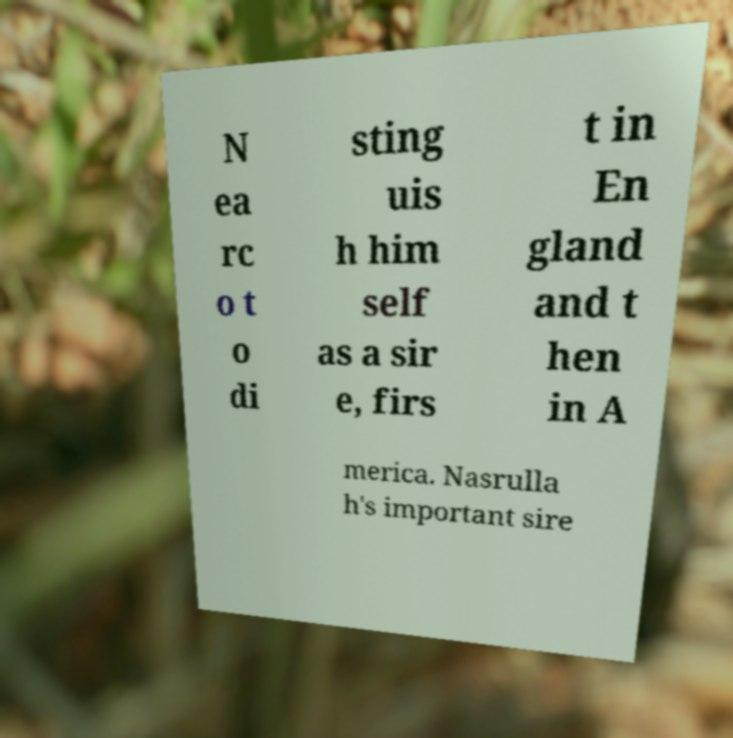There's text embedded in this image that I need extracted. Can you transcribe it verbatim? N ea rc o t o di sting uis h him self as a sir e, firs t in En gland and t hen in A merica. Nasrulla h's important sire 